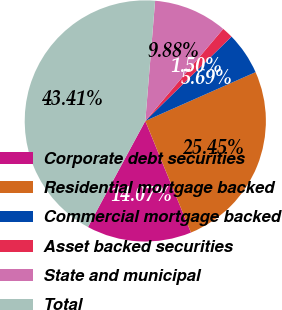Convert chart to OTSL. <chart><loc_0><loc_0><loc_500><loc_500><pie_chart><fcel>Corporate debt securities<fcel>Residential mortgage backed<fcel>Commercial mortgage backed<fcel>Asset backed securities<fcel>State and municipal<fcel>Total<nl><fcel>14.07%<fcel>25.45%<fcel>5.69%<fcel>1.5%<fcel>9.88%<fcel>43.41%<nl></chart> 